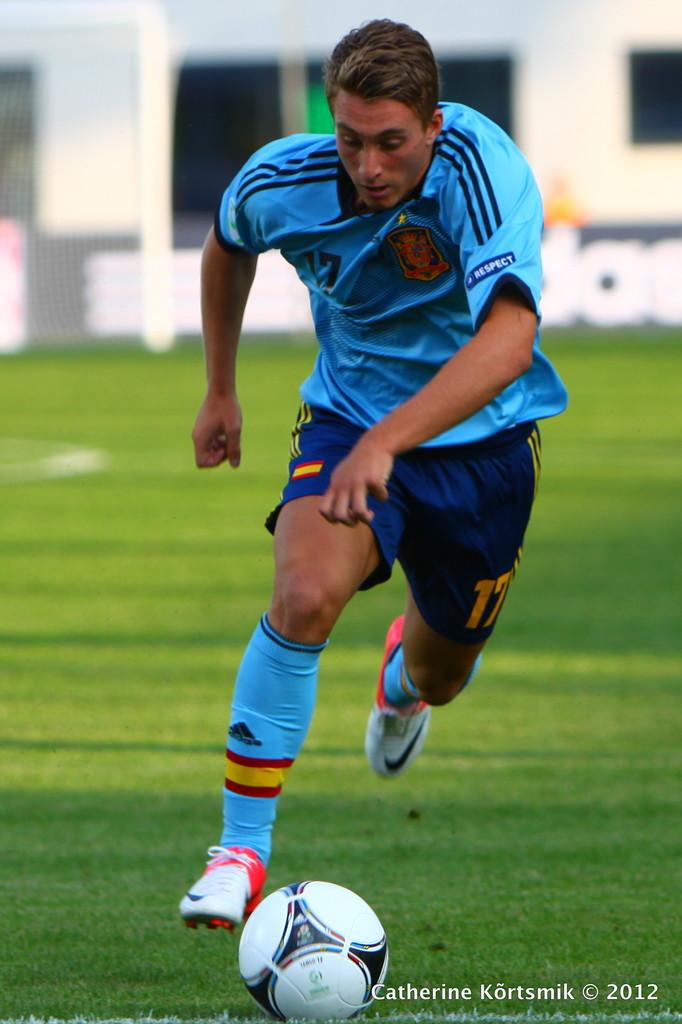Who is the main subject in the image? There is a man in the image. What is the man doing in the image? The man is playing football. Where is the man located in the image? The man is on a ground. What color is the man's t-shirt in the image? The man is wearing a blue t-shirt. What type of company is the man working for in the image? There is no indication in the image that the man is working for a company. 